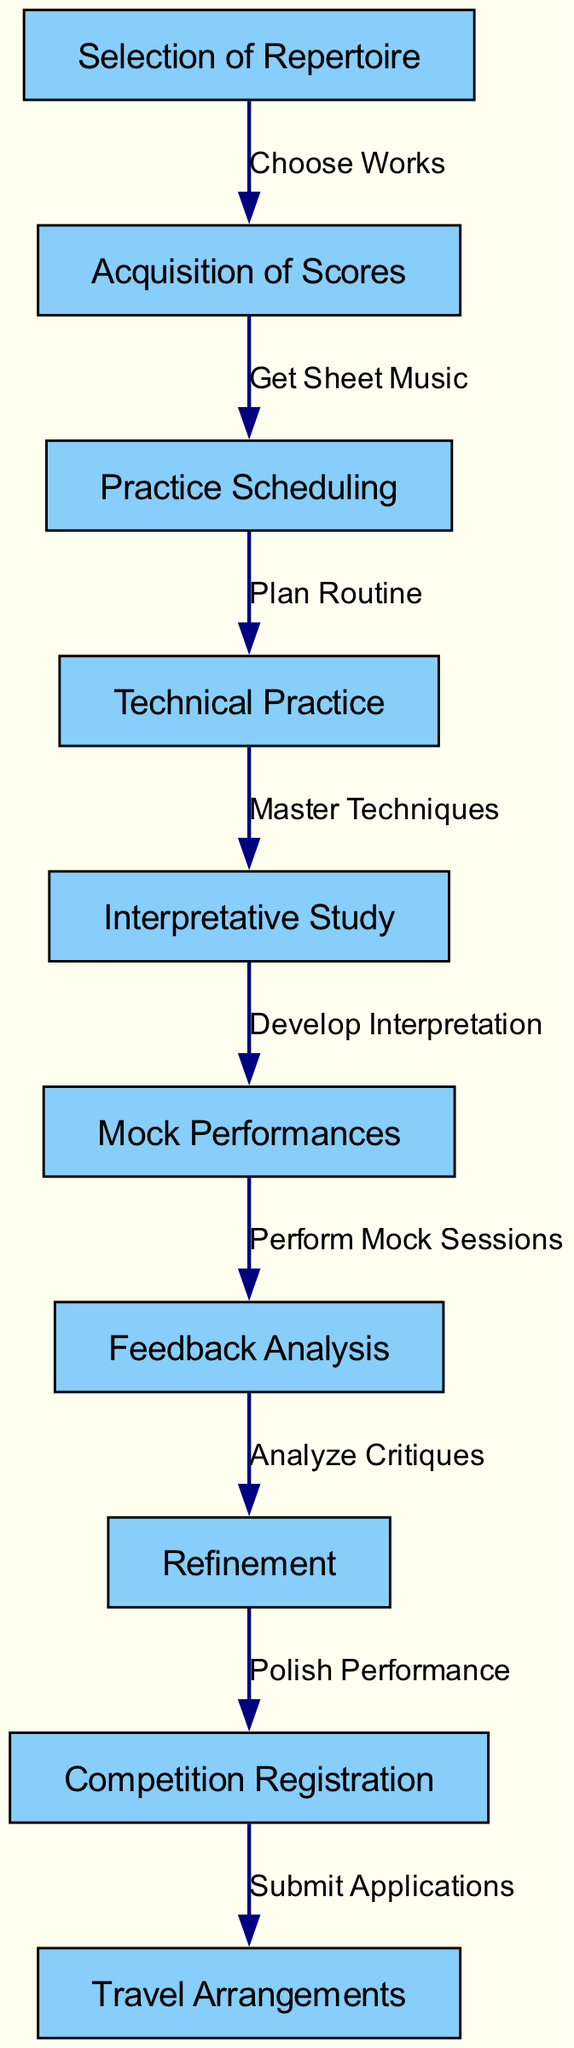What is the first step in preparing for the competition? The first node in the flowchart is "Selection of Repertoire". This indicates that before any other process begins, the musician must select the repertoire they will perform.
Answer: Selection of Repertoire How many nodes are present in the diagram? By counting the nodes listed in the data, we find there are ten distinct nodes present in the flowchart, each representing a step in the preparation process.
Answer: 10 What is the last step outlined in the preparation process? The final node in the flowchart is "Travel Arrangements", which indicates that after completing all other steps, the musician must finalize travel plans for the competition.
Answer: Travel Arrangements Which step comes after "Feedback Analysis"? According to the flowchart, after the "Feedback Analysis" step, the next step is "Refinement". This indicates that after analyzing feedback, the musician will refine their performance.
Answer: Refinement How many edges connect the nodes in the diagram? Counting the edges presented in the data reveals that there are nine connections between nodes that indicate the flow of the preparation process from one step to the next.
Answer: 9 What relationship does "Technical Practice" have with "Interpretative Study"? The edge between "Technical Practice" and "Interpretative Study" shows that after mastering techniques during technical practice, the musician moves on to develop their interpretation. The relationship is a direct progression in the preparation process.
Answer: Master Techniques What must be done after "Mock Performances"? The flowchart indicates that after completing "Mock Performances", the next step is "Feedback Analysis". This implies that the performances will be reviewed and critiqued after they are conducted.
Answer: Feedback Analysis What action is represented by the edge leading from "Competition Registration" to "Travel Arrangements"? The edge from "Competition Registration" to "Travel Arrangements" represents the action of submitting applications for the competition, which must be completed before making travel plans.
Answer: Submit Applications What is the purpose of "Interpretative Study" in the process? "Interpretative Study" serves the purpose of developing the musician's interpretation of pieces after the technical skills have been mastered during the preceding step, which shows how it builds on earlier practice.
Answer: Develop Interpretation 